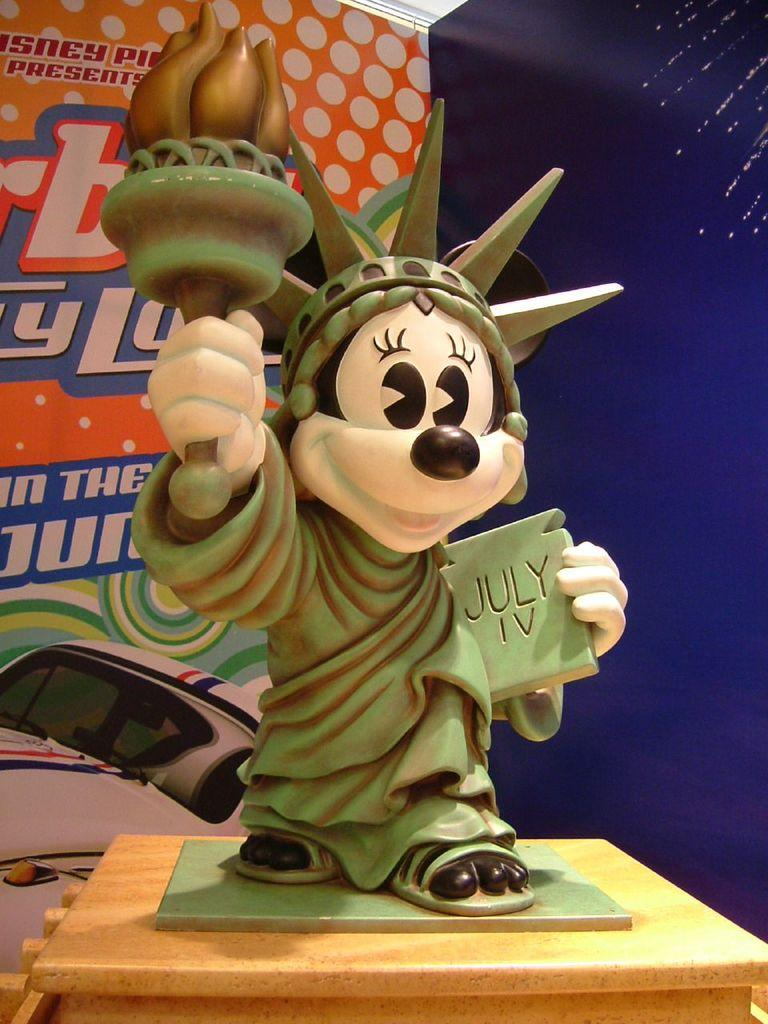What is the main subject in the foreground of the image? There is a sculpture in the foreground of the image. What is the sculpture placed on? The sculpture is on a wooden surface. What can be seen in the background of the image? There is a banner wall in the background of the image. What type of theory is being discussed on the seat in the image? There is no seat present in the image, and therefore no theory can be discussed. 